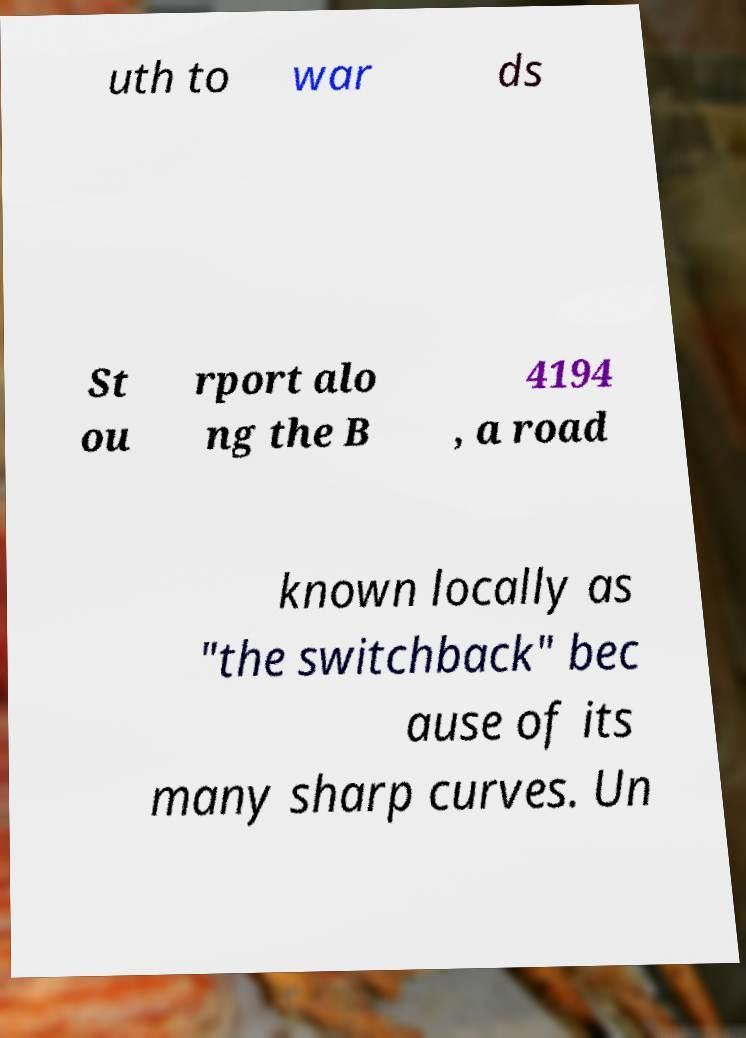There's text embedded in this image that I need extracted. Can you transcribe it verbatim? uth to war ds St ou rport alo ng the B 4194 , a road known locally as "the switchback" bec ause of its many sharp curves. Un 